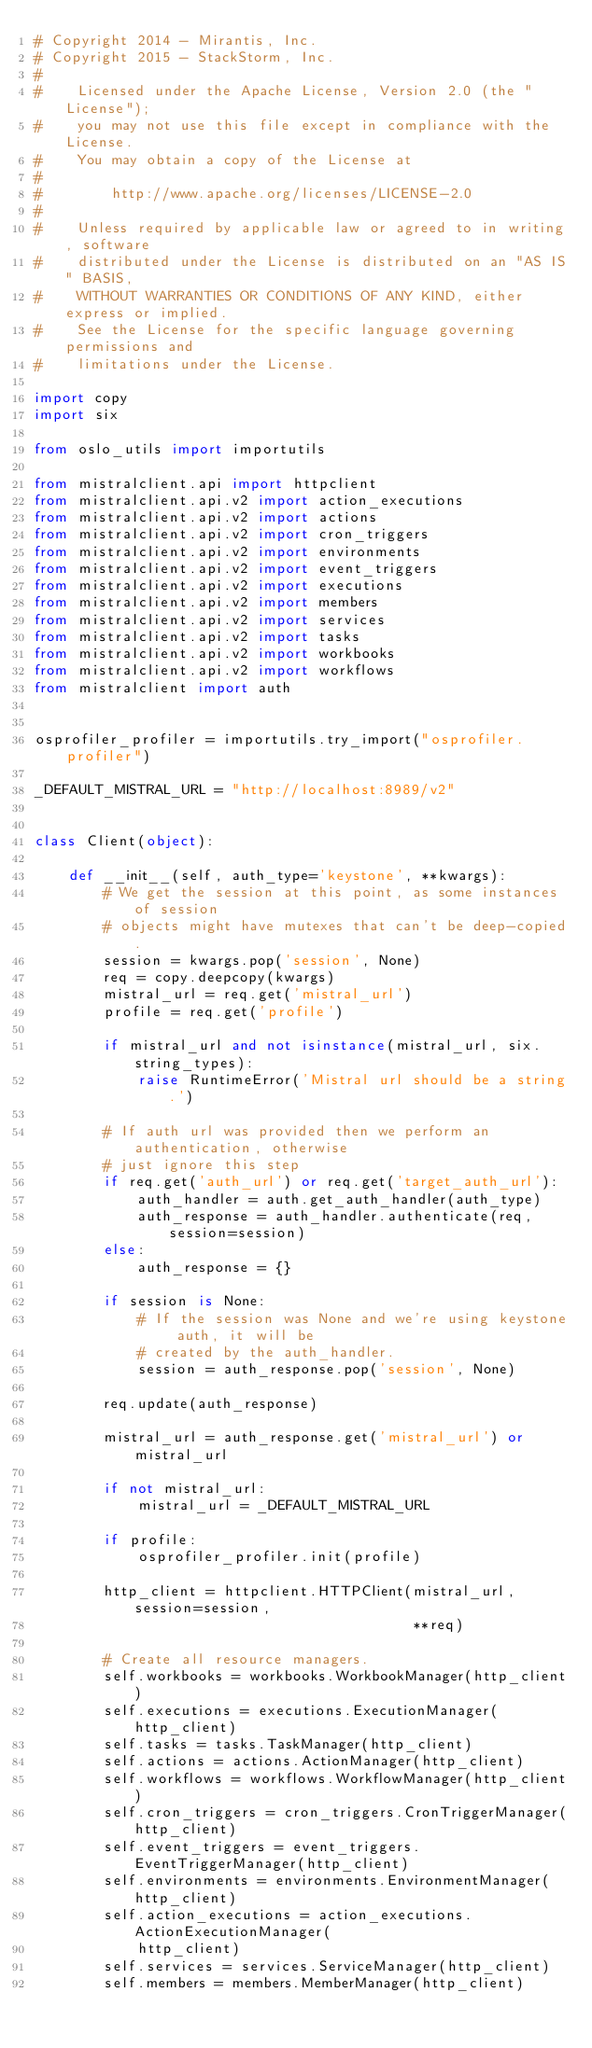Convert code to text. <code><loc_0><loc_0><loc_500><loc_500><_Python_># Copyright 2014 - Mirantis, Inc.
# Copyright 2015 - StackStorm, Inc.
#
#    Licensed under the Apache License, Version 2.0 (the "License");
#    you may not use this file except in compliance with the License.
#    You may obtain a copy of the License at
#
#        http://www.apache.org/licenses/LICENSE-2.0
#
#    Unless required by applicable law or agreed to in writing, software
#    distributed under the License is distributed on an "AS IS" BASIS,
#    WITHOUT WARRANTIES OR CONDITIONS OF ANY KIND, either express or implied.
#    See the License for the specific language governing permissions and
#    limitations under the License.

import copy
import six

from oslo_utils import importutils

from mistralclient.api import httpclient
from mistralclient.api.v2 import action_executions
from mistralclient.api.v2 import actions
from mistralclient.api.v2 import cron_triggers
from mistralclient.api.v2 import environments
from mistralclient.api.v2 import event_triggers
from mistralclient.api.v2 import executions
from mistralclient.api.v2 import members
from mistralclient.api.v2 import services
from mistralclient.api.v2 import tasks
from mistralclient.api.v2 import workbooks
from mistralclient.api.v2 import workflows
from mistralclient import auth


osprofiler_profiler = importutils.try_import("osprofiler.profiler")

_DEFAULT_MISTRAL_URL = "http://localhost:8989/v2"


class Client(object):

    def __init__(self, auth_type='keystone', **kwargs):
        # We get the session at this point, as some instances of session
        # objects might have mutexes that can't be deep-copied.
        session = kwargs.pop('session', None)
        req = copy.deepcopy(kwargs)
        mistral_url = req.get('mistral_url')
        profile = req.get('profile')

        if mistral_url and not isinstance(mistral_url, six.string_types):
            raise RuntimeError('Mistral url should be a string.')

        # If auth url was provided then we perform an authentication, otherwise
        # just ignore this step
        if req.get('auth_url') or req.get('target_auth_url'):
            auth_handler = auth.get_auth_handler(auth_type)
            auth_response = auth_handler.authenticate(req, session=session)
        else:
            auth_response = {}

        if session is None:
            # If the session was None and we're using keystone auth, it will be
            # created by the auth_handler.
            session = auth_response.pop('session', None)

        req.update(auth_response)

        mistral_url = auth_response.get('mistral_url') or mistral_url

        if not mistral_url:
            mistral_url = _DEFAULT_MISTRAL_URL

        if profile:
            osprofiler_profiler.init(profile)

        http_client = httpclient.HTTPClient(mistral_url, session=session,
                                            **req)

        # Create all resource managers.
        self.workbooks = workbooks.WorkbookManager(http_client)
        self.executions = executions.ExecutionManager(http_client)
        self.tasks = tasks.TaskManager(http_client)
        self.actions = actions.ActionManager(http_client)
        self.workflows = workflows.WorkflowManager(http_client)
        self.cron_triggers = cron_triggers.CronTriggerManager(http_client)
        self.event_triggers = event_triggers.EventTriggerManager(http_client)
        self.environments = environments.EnvironmentManager(http_client)
        self.action_executions = action_executions.ActionExecutionManager(
            http_client)
        self.services = services.ServiceManager(http_client)
        self.members = members.MemberManager(http_client)
</code> 